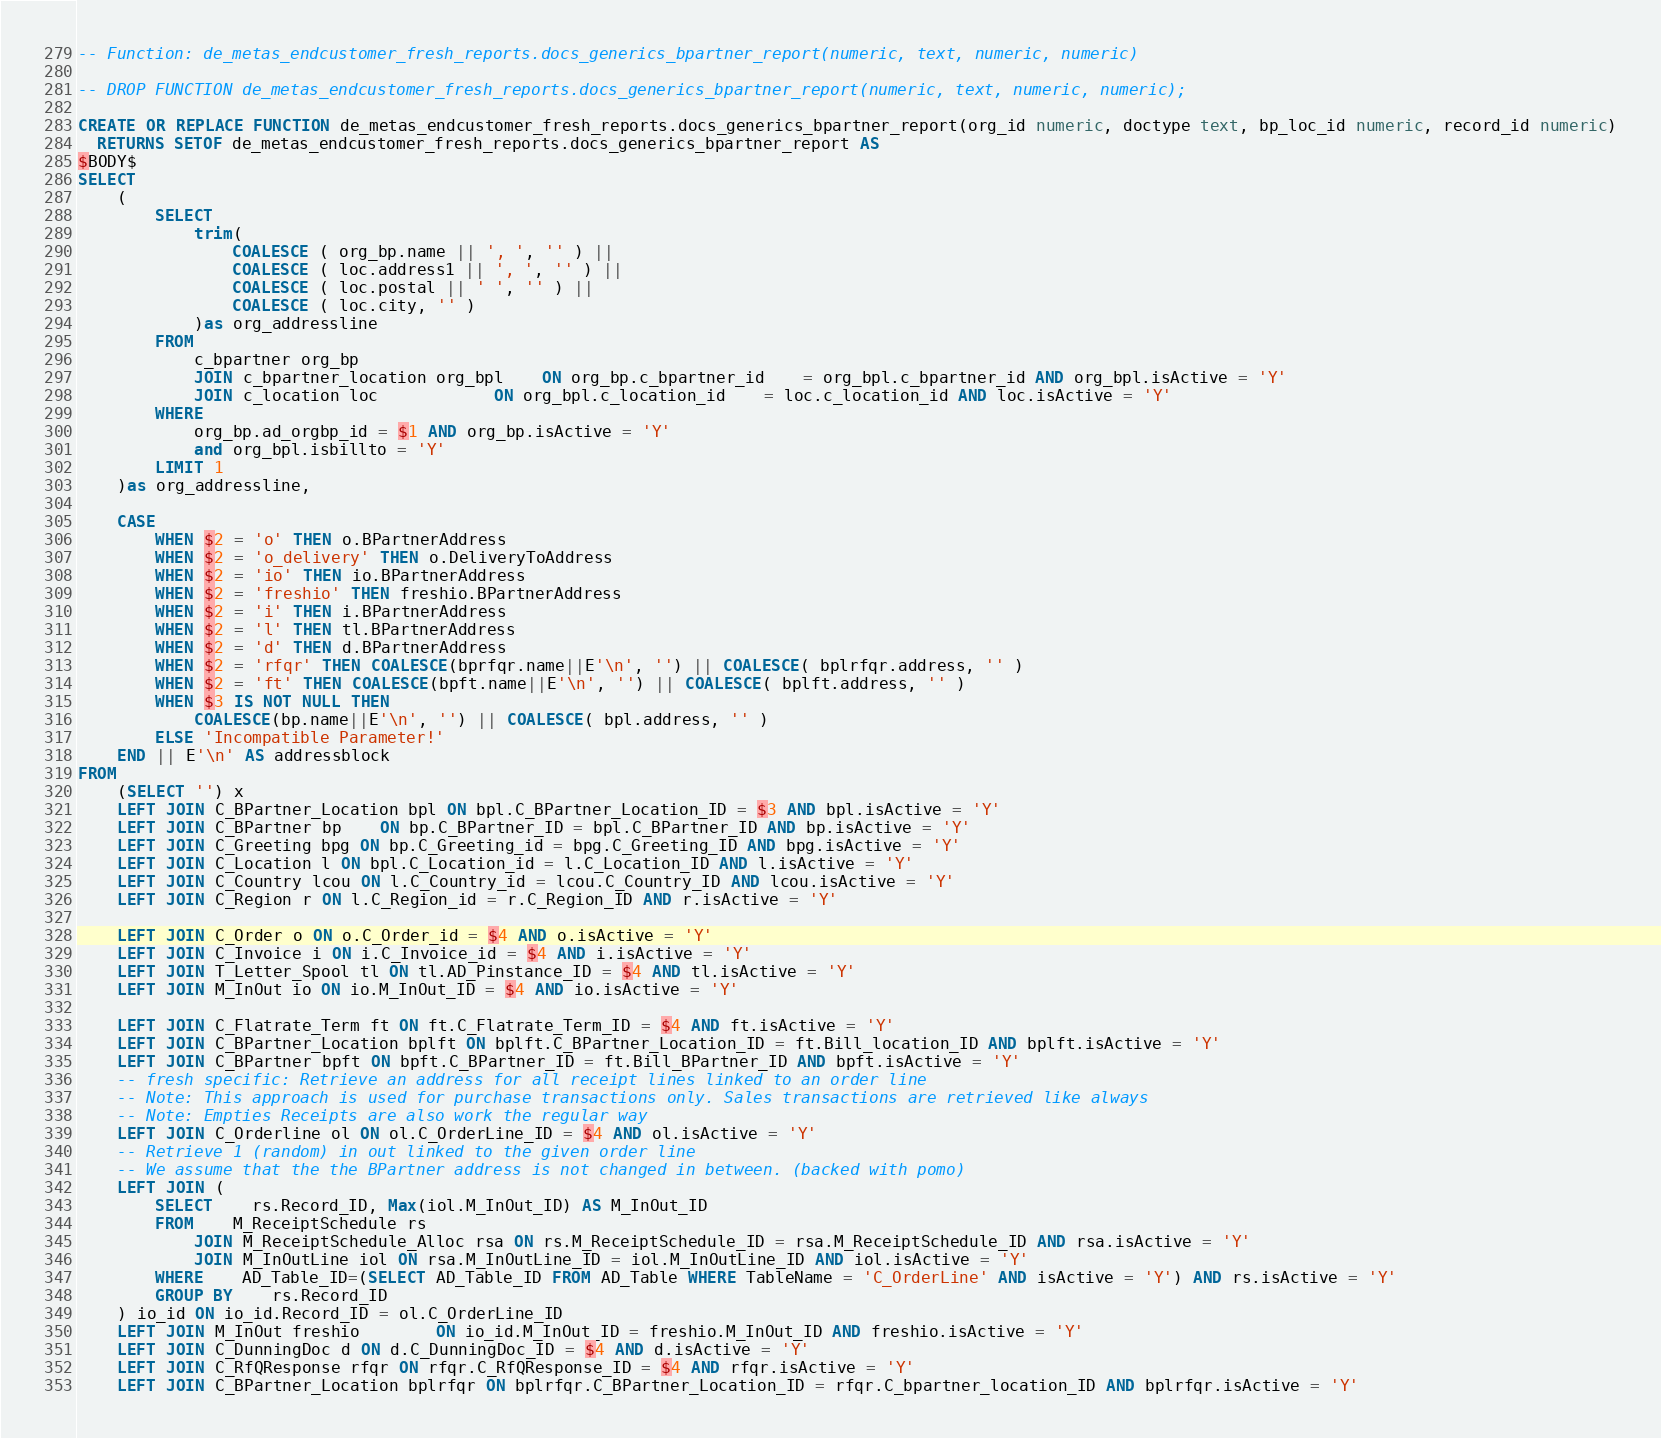Convert code to text. <code><loc_0><loc_0><loc_500><loc_500><_SQL_>-- Function: de_metas_endcustomer_fresh_reports.docs_generics_bpartner_report(numeric, text, numeric, numeric)

-- DROP FUNCTION de_metas_endcustomer_fresh_reports.docs_generics_bpartner_report(numeric, text, numeric, numeric);

CREATE OR REPLACE FUNCTION de_metas_endcustomer_fresh_reports.docs_generics_bpartner_report(org_id numeric, doctype text, bp_loc_id numeric, record_id numeric)
  RETURNS SETOF de_metas_endcustomer_fresh_reports.docs_generics_bpartner_report AS
$BODY$
SELECT
	(
		SELECT
			trim(
				COALESCE ( org_bp.name || ', ', '' ) ||
				COALESCE ( loc.address1 || ', ', '' ) ||
				COALESCE ( loc.postal || ' ', '' ) ||
				COALESCE ( loc.city, '' )
			)as org_addressline
		FROM
			c_bpartner org_bp
			JOIN c_bpartner_location org_bpl 	ON org_bp.c_bpartner_id	= org_bpl.c_bpartner_id AND org_bpl.isActive = 'Y'
			JOIN c_location loc	 		ON org_bpl.c_location_id	= loc.c_location_id AND loc.isActive = 'Y'
		WHERE
			org_bp.ad_orgbp_id = $1 AND org_bp.isActive = 'Y'
			and org_bpl.isbillto = 'Y'
		LIMIT 1
	)as org_addressline,

	CASE
		WHEN $2 = 'o' THEN o.BPartnerAddress
		WHEN $2 = 'o_delivery' THEN o.DeliveryToAddress
		WHEN $2 = 'io' THEN io.BPartnerAddress
		WHEN $2 = 'freshio' THEN freshio.BPartnerAddress
		WHEN $2 = 'i' THEN i.BPartnerAddress
		WHEN $2 = 'l' THEN tl.BPartnerAddress
		WHEN $2 = 'd' THEN d.BPartnerAddress
		WHEN $2 = 'rfqr' THEN COALESCE(bprfqr.name||E'\n', '') || COALESCE( bplrfqr.address, '' )
		WHEN $2 = 'ft' THEN COALESCE(bpft.name||E'\n', '') || COALESCE( bplft.address, '' )
		WHEN $3 IS NOT NULL THEN
			COALESCE(bp.name||E'\n', '') || COALESCE( bpl.address, '' )
		ELSE 'Incompatible Parameter!'
	END || E'\n' AS addressblock
FROM
	(SELECT '') x
	LEFT JOIN C_BPartner_Location bpl ON bpl.C_BPartner_Location_ID = $3 AND bpl.isActive = 'Y'
	LEFT JOIN C_BPartner bp	ON bp.C_BPartner_ID = bpl.C_BPartner_ID AND bp.isActive = 'Y'
	LEFT JOIN C_Greeting bpg ON bp.C_Greeting_id = bpg.C_Greeting_ID AND bpg.isActive = 'Y'
	LEFT JOIN C_Location l ON bpl.C_Location_id = l.C_Location_ID AND l.isActive = 'Y'
	LEFT JOIN C_Country lcou ON l.C_Country_id = lcou.C_Country_ID AND lcou.isActive = 'Y'
	LEFT JOIN C_Region r ON l.C_Region_id = r.C_Region_ID AND r.isActive = 'Y'

	LEFT JOIN C_Order o ON o.C_Order_id = $4 AND o.isActive = 'Y'
	LEFT JOIN C_Invoice i ON i.C_Invoice_id = $4 AND i.isActive = 'Y'
	LEFT JOIN T_Letter_Spool tl ON tl.AD_Pinstance_ID = $4 AND tl.isActive = 'Y'
	LEFT JOIN M_InOut io ON io.M_InOut_ID = $4 AND io.isActive = 'Y'

	LEFT JOIN C_Flatrate_Term ft ON ft.C_Flatrate_Term_ID = $4 AND ft.isActive = 'Y'
	LEFT JOIN C_BPartner_Location bplft ON bplft.C_BPartner_Location_ID = ft.Bill_location_ID AND bplft.isActive = 'Y'
	LEFT JOIN C_BPartner bpft ON bpft.C_BPartner_ID = ft.Bill_BPartner_ID AND bpft.isActive = 'Y'
	-- fresh specific: Retrieve an address for all receipt lines linked to an order line
	-- Note: This approach is used for purchase transactions only. Sales transactions are retrieved like always
	-- Note: Empties Receipts are also work the regular way
	LEFT JOIN C_Orderline ol ON ol.C_OrderLine_ID = $4 AND ol.isActive = 'Y'
	-- Retrieve 1 (random) in out linked to the given order line
	-- We assume that the the BPartner address is not changed in between. (backed with pomo)
	LEFT JOIN (
		SELECT 	rs.Record_ID, Max(iol.M_InOut_ID) AS M_InOut_ID
		FROM 	M_ReceiptSchedule rs
			JOIN M_ReceiptSchedule_Alloc rsa ON rs.M_ReceiptSchedule_ID = rsa.M_ReceiptSchedule_ID AND rsa.isActive = 'Y'
			JOIN M_InOutLine iol ON rsa.M_InOutLine_ID = iol.M_InOutLine_ID AND iol.isActive = 'Y'
		WHERE	AD_Table_ID=(SELECT AD_Table_ID FROM AD_Table WHERE TableName = 'C_OrderLine' AND isActive = 'Y') AND rs.isActive = 'Y'
		GROUP BY	rs.Record_ID
	) io_id ON io_id.Record_ID = ol.C_OrderLine_ID
	LEFT JOIN M_InOut freshio 		ON io_id.M_InOut_ID = freshio.M_InOut_ID AND freshio.isActive = 'Y'
	LEFT JOIN C_DunningDoc d ON d.C_DunningDoc_ID = $4 AND d.isActive = 'Y'
	LEFT JOIN C_RfQResponse rfqr ON rfqr.C_RfQResponse_ID = $4 AND rfqr.isActive = 'Y'
	LEFT JOIN C_BPartner_Location bplrfqr ON bplrfqr.C_BPartner_Location_ID = rfqr.C_bpartner_location_ID AND bplrfqr.isActive = 'Y'</code> 